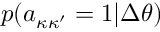Convert formula to latex. <formula><loc_0><loc_0><loc_500><loc_500>p ( a _ { \kappa \kappa ^ { \prime } } = 1 | \Delta \theta )</formula> 